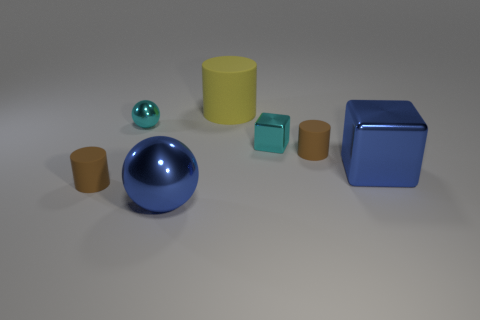Subtract all yellow blocks. How many brown cylinders are left? 2 Subtract 1 cylinders. How many cylinders are left? 2 Add 2 tiny red matte spheres. How many objects exist? 9 Subtract all cylinders. How many objects are left? 4 Add 1 big yellow rubber cylinders. How many big yellow rubber cylinders are left? 2 Add 7 large green spheres. How many large green spheres exist? 7 Subtract 0 red spheres. How many objects are left? 7 Subtract all green metal things. Subtract all tiny spheres. How many objects are left? 6 